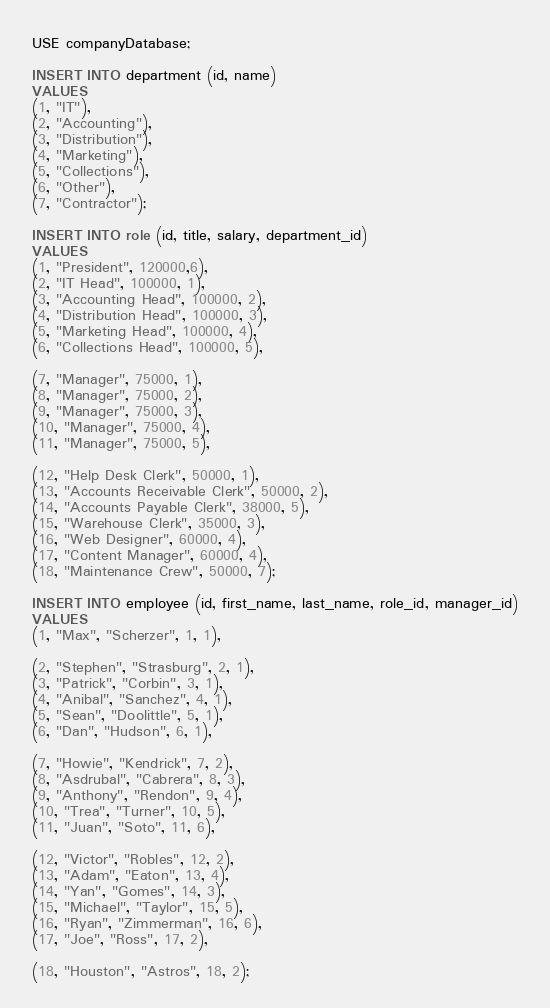<code> <loc_0><loc_0><loc_500><loc_500><_SQL_>USE companyDatabase;

INSERT INTO department (id, name)
VALUES 
(1, "IT"), 
(2, "Accounting"), 
(3, "Distribution"), 
(4, "Marketing"),
(5, "Collections"),
(6, "Other"),
(7, "Contractor");

INSERT INTO role (id, title, salary, department_id)
VALUES 
(1, "President", 120000,6),
(2, "IT Head", 100000, 1), 
(3, "Accounting Head", 100000, 2), 
(4, "Distribution Head", 100000, 3), 
(5, "Marketing Head", 100000, 4), 
(6, "Collections Head", 100000, 5),

(7, "Manager", 75000, 1), 
(8, "Manager", 75000, 2), 
(9, "Manager", 75000, 3), 
(10, "Manager", 75000, 4), 
(11, "Manager", 75000, 5), 

(12, "Help Desk Clerk", 50000, 1),
(13, "Accounts Receivable Clerk", 50000, 2),
(14, "Accounts Payable Clerk", 38000, 5),
(15, "Warehouse Clerk", 35000, 3),
(16, "Web Designer", 60000, 4),
(17, "Content Manager", 60000, 4),
(18, "Maintenance Crew", 50000, 7);

INSERT INTO employee (id, first_name, last_name, role_id, manager_id)
VALUES 
(1, "Max", "Scherzer", 1, 1), 

(2, "Stephen", "Strasburg", 2, 1), 
(3, "Patrick", "Corbin", 3, 1), 
(4, "Anibal", "Sanchez", 4, 1), 
(5, "Sean", "Doolittle", 5, 1), 
(6, "Dan", "Hudson", 6, 1),

(7, "Howie", "Kendrick", 7, 2),
(8, "Asdrubal", "Cabrera", 8, 3),
(9, "Anthony", "Rendon", 9, 4),
(10, "Trea", "Turner", 10, 5),
(11, "Juan", "Soto", 11, 6),

(12, "Victor", "Robles", 12, 2),
(13, "Adam", "Eaton", 13, 4),
(14, "Yan", "Gomes", 14, 3),
(15, "Michael", "Taylor", 15, 5),
(16, "Ryan", "Zimmerman", 16, 6),
(17, "Joe", "Ross", 17, 2),

(18, "Houston", "Astros", 18, 2);</code> 